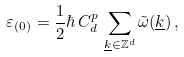<formula> <loc_0><loc_0><loc_500><loc_500>\varepsilon _ { ( 0 ) } = \frac { 1 } { 2 } \hbar { \, } C ^ { p } _ { d } \, \sum _ { \underline { k } \in \mathbb { Z } ^ { d } } \tilde { \omega } ( \underline { k } ) \, ,</formula> 